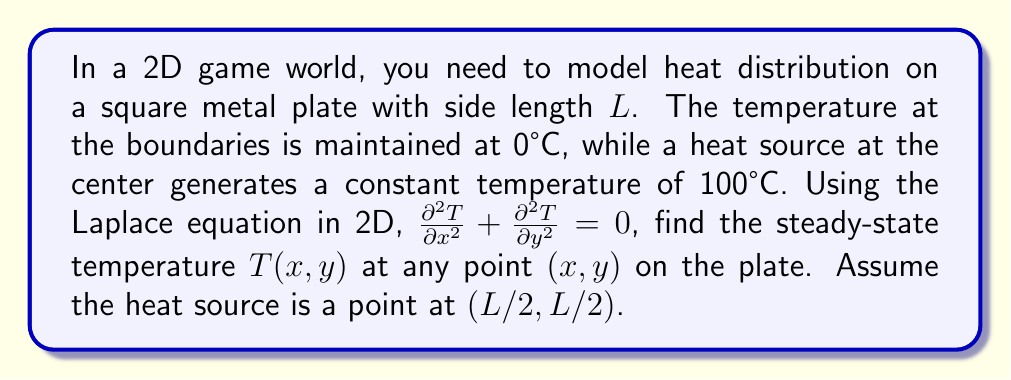Show me your answer to this math problem. To solve this problem, we'll use separation of variables and Fourier series:

1) The general solution for the Laplace equation in 2D is:
   $$T(x,y) = \sum_{n=1}^{\infty} (A_n \sinh(\frac{n\pi x}{L}) + B_n \sinh(\frac{n\pi (L-x)}{L})) \sin(\frac{n\pi y}{L})$$

2) Apply boundary conditions:
   - $T(0,y) = T(L,y) = T(x,0) = T(x,L) = 0$ (already satisfied by the general solution)
   - $T(L/2, L/2) = 100$ (heat source)

3) The solution should be symmetric about $x=L/2$ and $y=L/2$, so $A_n = B_n$:
   $$T(x,y) = \sum_{n=1}^{\infty} A_n (\sinh(\frac{n\pi x}{L}) + \sinh(\frac{n\pi (L-x)}{L})) \sin(\frac{n\pi y}{L})$$

4) Use the heat source condition:
   $$100 = \sum_{n=1}^{\infty} 2A_n \sinh(\frac{n\pi L}{2L}) \sin(\frac{n\pi L}{2L})$$

5) Multiply both sides by $\sin(\frac{m\pi L}{2L})$ and integrate from 0 to L:
   $$100 \cdot \frac{L}{2} = A_m \sinh(\frac{m\pi}{2}) \cdot \frac{L}{2}$$

6) Solve for $A_m$:
   $$A_m = \frac{100}{\sinh(\frac{m\pi}{2})}$$

7) The final solution is:
   $$T(x,y) = \sum_{n=1}^{\infty} \frac{100}{\sinh(\frac{n\pi}{2})} (\sinh(\frac{n\pi x}{L}) + \sinh(\frac{n\pi (L-x)}{L})) \sin(\frac{n\pi y}{L})$$

This solution gives the temperature at any point $(x,y)$ on the plate.
Answer: $$T(x,y) = \sum_{n=1}^{\infty} \frac{100}{\sinh(\frac{n\pi}{2})} (\sinh(\frac{n\pi x}{L}) + \sinh(\frac{n\pi (L-x)}{L})) \sin(\frac{n\pi y}{L})$$ 